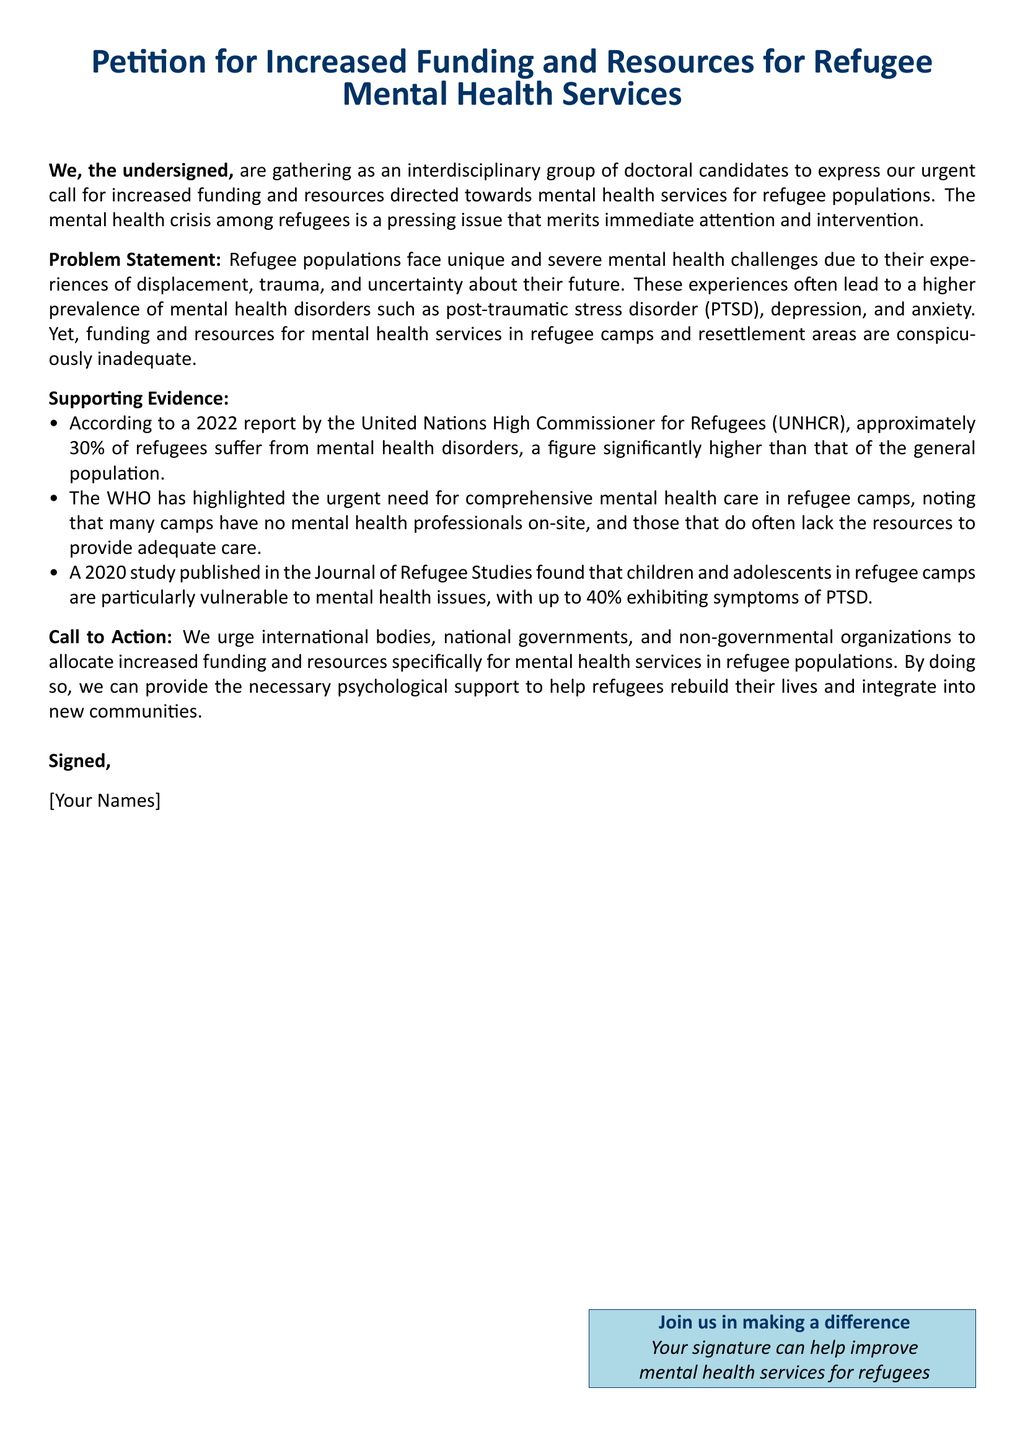What is the main focus of the petition? The petition primarily focuses on advocating for increased funding and resources for mental health services for refugee populations.
Answer: Increased funding and resources for refugee mental health services What percentage of refugees suffer from mental health disorders according to the UNHCR report? The document states that approximately 30% of refugees suffer from mental health disorders, as indicated by the 2022 UNHCR report.
Answer: 30% What mental health issue is specifically noted as prevalent among children in refugee camps? The document highlights that up to 40% of children and adolescents in refugee camps exhibit symptoms of PTSD.
Answer: Symptoms of PTSD Who is urging the call for action regarding funding? The petition is endorsed by an interdisciplinary group of doctoral candidates.
Answer: An interdisciplinary group of doctoral candidates What organization is mentioned for emphasizing the need for mental health care in refugee camps? The World Health Organization (WHO) is mentioned in the document as highlighting the need for comprehensive mental health care in refugee camps.
Answer: World Health Organization (WHO) What is the document type of this content? The document is a petition calling for action to improve mental health services for refugees.
Answer: Petition 